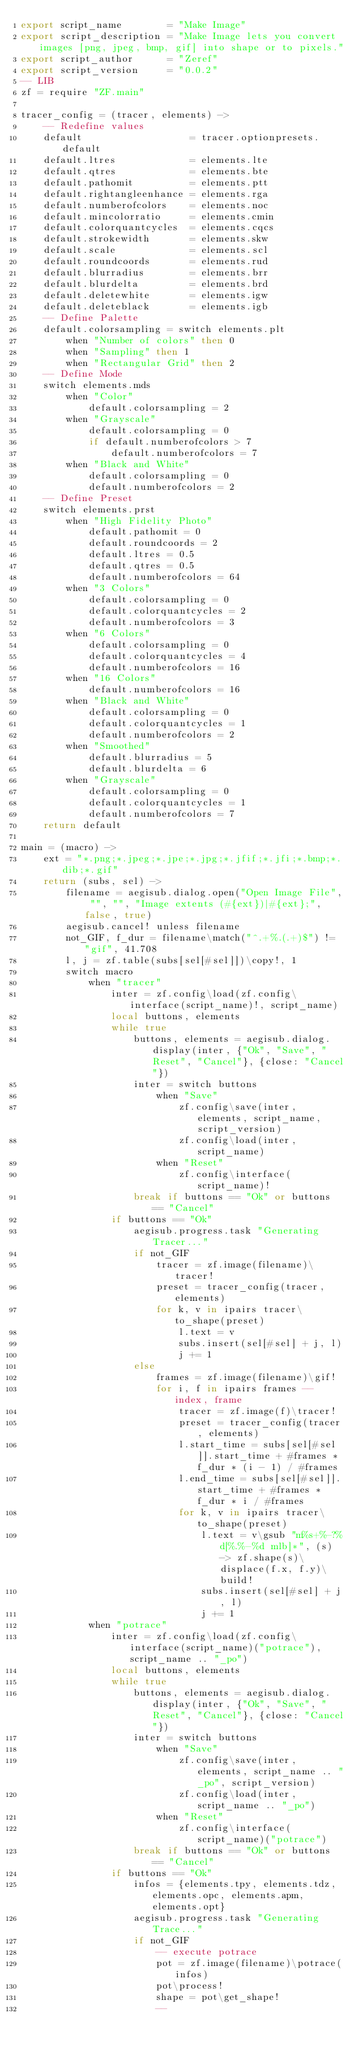<code> <loc_0><loc_0><loc_500><loc_500><_MoonScript_>export script_name        = "Make Image"
export script_description = "Make Image lets you convert images [png, jpeg, bmp, gif] into shape or to pixels."
export script_author      = "Zeref"
export script_version     = "0.0.2"
-- LIB
zf = require "ZF.main"

tracer_config = (tracer, elements) ->
    -- Redefine values
    default                   = tracer.optionpresets.default
    default.ltres             = elements.lte
    default.qtres             = elements.bte
    default.pathomit          = elements.ptt
    default.rightangleenhance = elements.rga
    default.numberofcolors    = elements.noc
    default.mincolorratio     = elements.cmin
    default.colorquantcycles  = elements.cqcs
    default.strokewidth       = elements.skw 
    default.scale             = elements.scl
    default.roundcoords       = elements.rud
    default.blurradius        = elements.brr
    default.blurdelta         = elements.brd
    default.deletewhite       = elements.igw
    default.deleteblack       = elements.igb
    -- Define Palette
    default.colorsampling = switch elements.plt
        when "Number of colors" then 0
        when "Sampling" then 1
        when "Rectangular Grid" then 2
    -- Define Mode
    switch elements.mds
        when "Color"
            default.colorsampling = 2
        when "Grayscale"
            default.colorsampling = 0
            if default.numberofcolors > 7
                default.numberofcolors = 7
        when "Black and White"
            default.colorsampling = 0
            default.numberofcolors = 2
    -- Define Preset
    switch elements.prst
        when "High Fidelity Photo"
            default.pathomit = 0
            default.roundcoords = 2
            default.ltres = 0.5
            default.qtres = 0.5
            default.numberofcolors = 64
        when "3 Colors"
            default.colorsampling = 0
            default.colorquantcycles = 2
            default.numberofcolors = 3
        when "6 Colors"
            default.colorsampling = 0
            default.colorquantcycles = 4
            default.numberofcolors = 16
        when "16 Colors"
            default.numberofcolors = 16
        when "Black and White"
            default.colorsampling = 0
            default.colorquantcycles = 1
            default.numberofcolors = 2
        when "Smoothed"
            default.blurradius = 5
            default.blurdelta = 6
        when "Grayscale"
            default.colorsampling = 0
            default.colorquantcycles = 1
            default.numberofcolors = 7
    return default

main = (macro) ->
    ext = "*.png;*.jpeg;*.jpe;*.jpg;*.jfif;*.jfi;*.bmp;*.dib;*.gif"
    return (subs, sel) ->
        filename = aegisub.dialog.open("Open Image File", "", "", "Image extents (#{ext})|#{ext};", false, true)
        aegisub.cancel! unless filename
        not_GIF, f_dur = filename\match("^.+%.(.+)$") != "gif", 41.708
        l, j = zf.table(subs[sel[#sel]])\copy!, 1
        switch macro
            when "tracer"
                inter = zf.config\load(zf.config\interface(script_name)!, script_name)
                local buttons, elements
                while true
                    buttons, elements = aegisub.dialog.display(inter, {"Ok", "Save", "Reset", "Cancel"}, {close: "Cancel"})
                    inter = switch buttons
                        when "Save"
                            zf.config\save(inter, elements, script_name, script_version)
                            zf.config\load(inter, script_name)
                        when "Reset"
                            zf.config\interface(script_name)!
                    break if buttons == "Ok" or buttons == "Cancel"
                if buttons == "Ok"
                    aegisub.progress.task "Generating Tracer..."
                    if not_GIF
                        tracer = zf.image(filename)\tracer!
                        preset = tracer_config(tracer, elements)
                        for k, v in ipairs tracer\to_shape(preset)
                            l.text = v
                            subs.insert(sel[#sel] + j, l)
                            j += 1
                    else
                        frames = zf.image(filename)\gif!
                        for i, f in ipairs frames -- index, frame
                            tracer = zf.image(f)\tracer!
                            preset = tracer_config(tracer, elements)
                            l.start_time = subs[sel[#sel]].start_time + #frames * f_dur * (i - 1) / #frames
                            l.end_time = subs[sel[#sel]].start_time + #frames * f_dur * i / #frames
                            for k, v in ipairs tracer\to_shape(preset)
                                l.text = v\gsub "m%s+%-?%d[%.%-%d mlb]*", (s) -> zf.shape(s)\displace(f.x, f.y)\build!
                                subs.insert(sel[#sel] + j, l)
                                j += 1
            when "potrace"
                inter = zf.config\load(zf.config\interface(script_name)("potrace"), script_name .. "_po")
                local buttons, elements
                while true
                    buttons, elements = aegisub.dialog.display(inter, {"Ok", "Save", "Reset", "Cancel"}, {close: "Cancel"})
                    inter = switch buttons
                        when "Save"
                            zf.config\save(inter, elements, script_name .. "_po", script_version)
                            zf.config\load(inter, script_name .. "_po")
                        when "Reset"
                            zf.config\interface(script_name)("potrace")
                    break if buttons == "Ok" or buttons == "Cancel"
                if buttons == "Ok"
                    infos = {elements.tpy, elements.tdz, elements.opc, elements.apm, elements.opt}
                    aegisub.progress.task "Generating Trace..."
                    if not_GIF
                        -- execute potrace
                        pot = zf.image(filename)\potrace(infos)
                        pot\process!
                        shape = pot\get_shape!
                        --</code> 